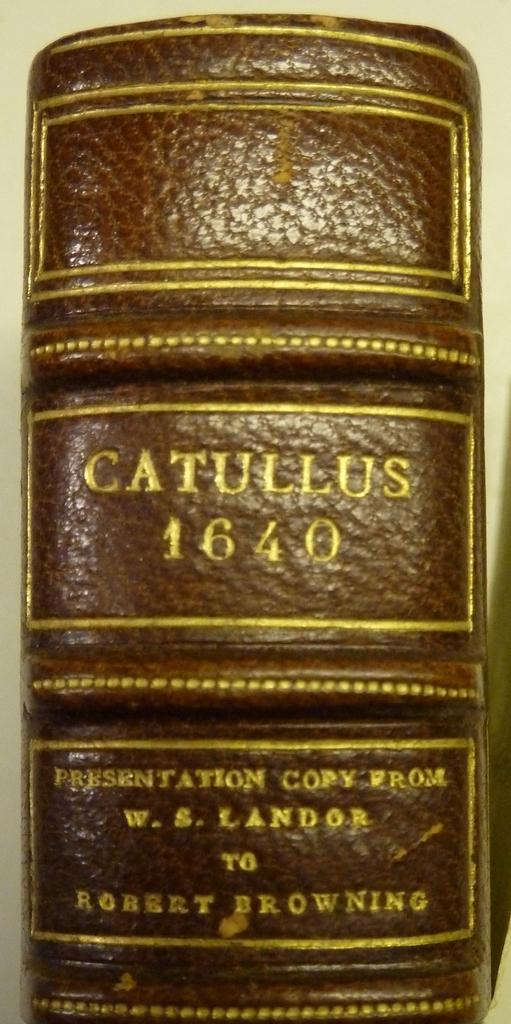<image>
Describe the image concisely. The spine of a book that says Catullus 1640 